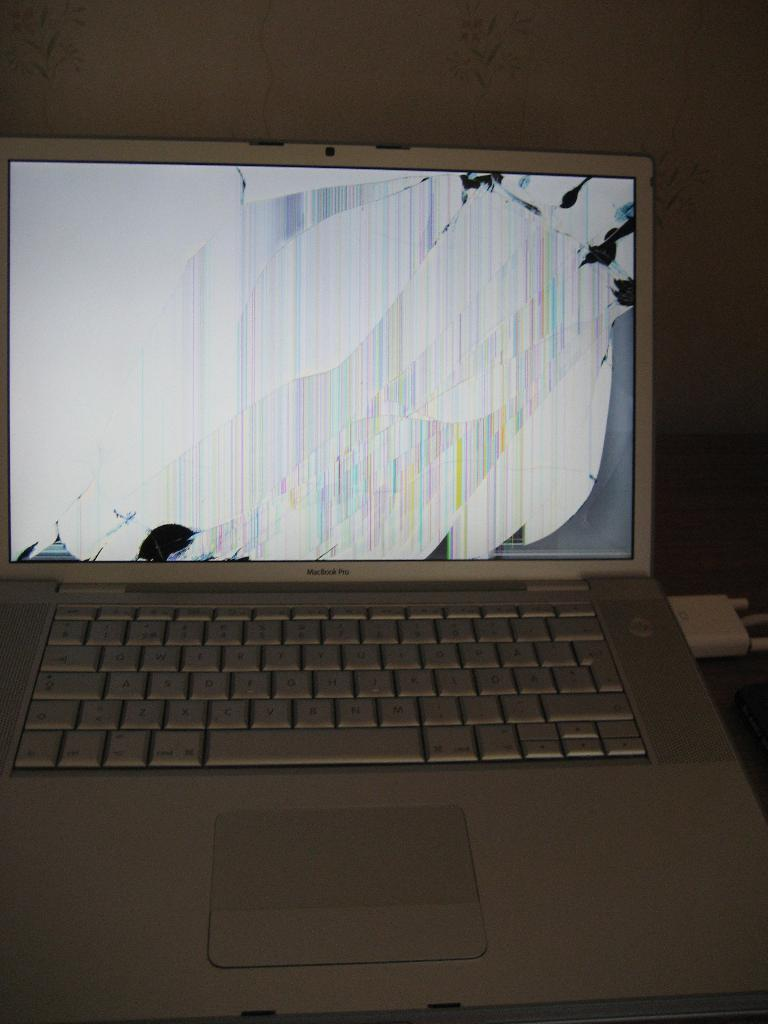<image>
Relay a brief, clear account of the picture shown. Macbook Pro laptop with a broken screen showing only white. 